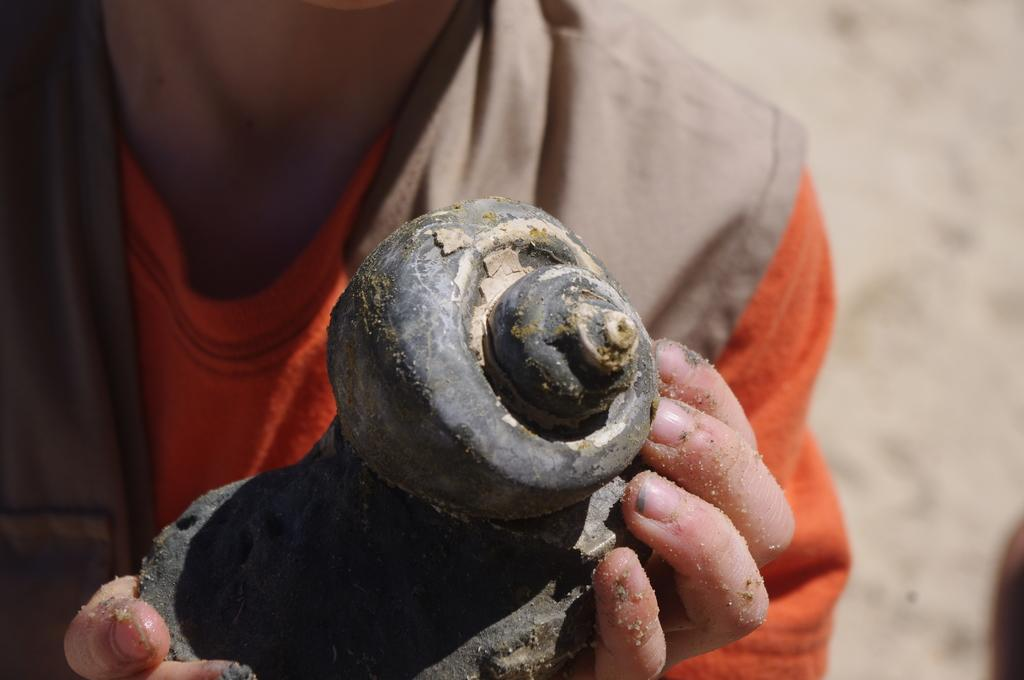What can be seen in the image? There is a person in the image. What is the person doing in the image? The person is holding an object in their hands. Can you describe the background of the image? The background of the image is blurry. What type of hair can be seen on the head of the person in the image? There is no information about the person's hair in the image, as the background is blurry and the focus is on the person holding an object. 